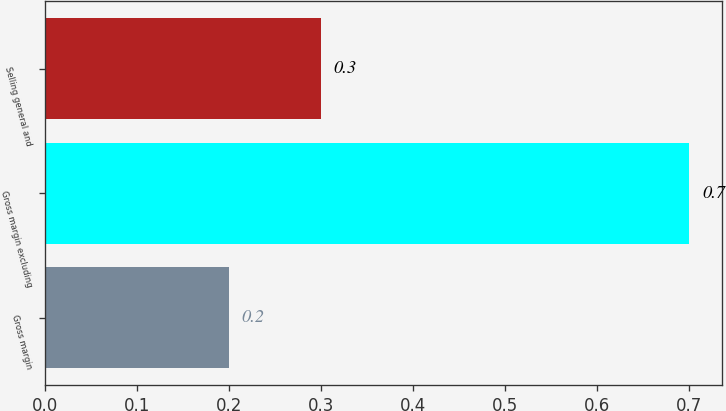<chart> <loc_0><loc_0><loc_500><loc_500><bar_chart><fcel>Gross margin<fcel>Gross margin excluding<fcel>Selling general and<nl><fcel>0.2<fcel>0.7<fcel>0.3<nl></chart> 